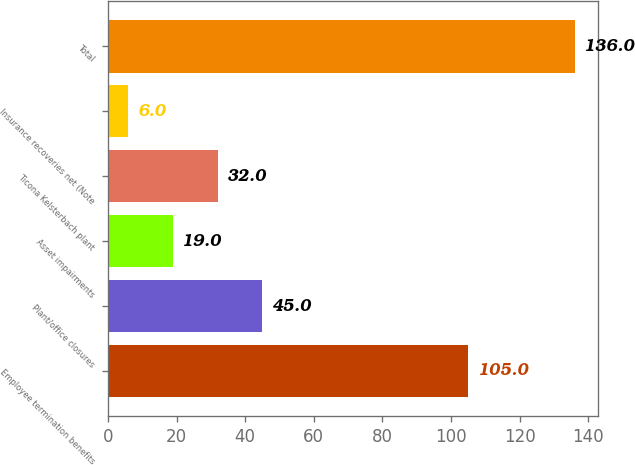Convert chart to OTSL. <chart><loc_0><loc_0><loc_500><loc_500><bar_chart><fcel>Employee termination benefits<fcel>Plant/office closures<fcel>Asset impairments<fcel>Ticona Kelsterbach plant<fcel>Insurance recoveries net (Note<fcel>Total<nl><fcel>105<fcel>45<fcel>19<fcel>32<fcel>6<fcel>136<nl></chart> 